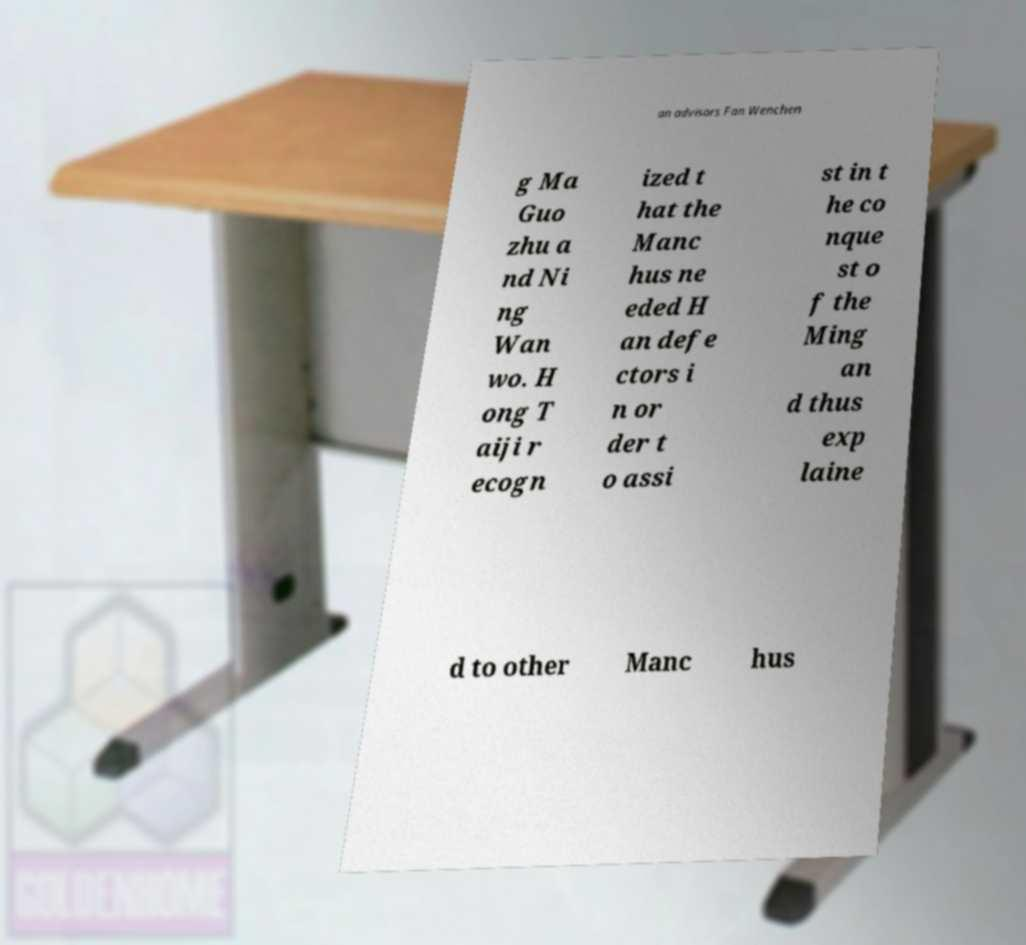What messages or text are displayed in this image? I need them in a readable, typed format. an advisors Fan Wenchen g Ma Guo zhu a nd Ni ng Wan wo. H ong T aiji r ecogn ized t hat the Manc hus ne eded H an defe ctors i n or der t o assi st in t he co nque st o f the Ming an d thus exp laine d to other Manc hus 